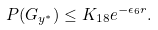<formula> <loc_0><loc_0><loc_500><loc_500>P ( G _ { y ^ { * } } ) \leq K _ { 1 8 } e ^ { - \epsilon _ { 6 } r } .</formula> 